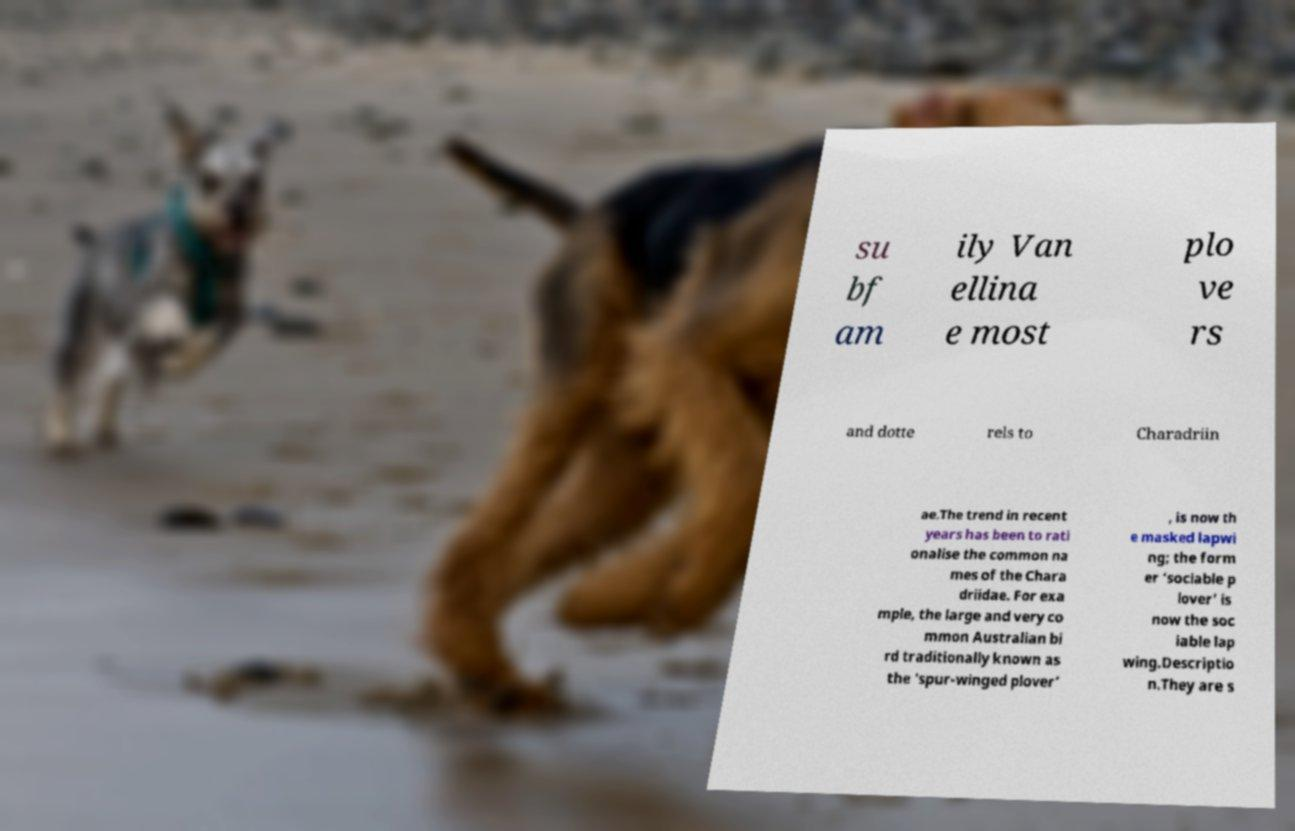For documentation purposes, I need the text within this image transcribed. Could you provide that? su bf am ily Van ellina e most plo ve rs and dotte rels to Charadriin ae.The trend in recent years has been to rati onalise the common na mes of the Chara driidae. For exa mple, the large and very co mmon Australian bi rd traditionally known as the ‘spur-winged plover’ , is now th e masked lapwi ng; the form er ‘sociable p lover’ is now the soc iable lap wing.Descriptio n.They are s 